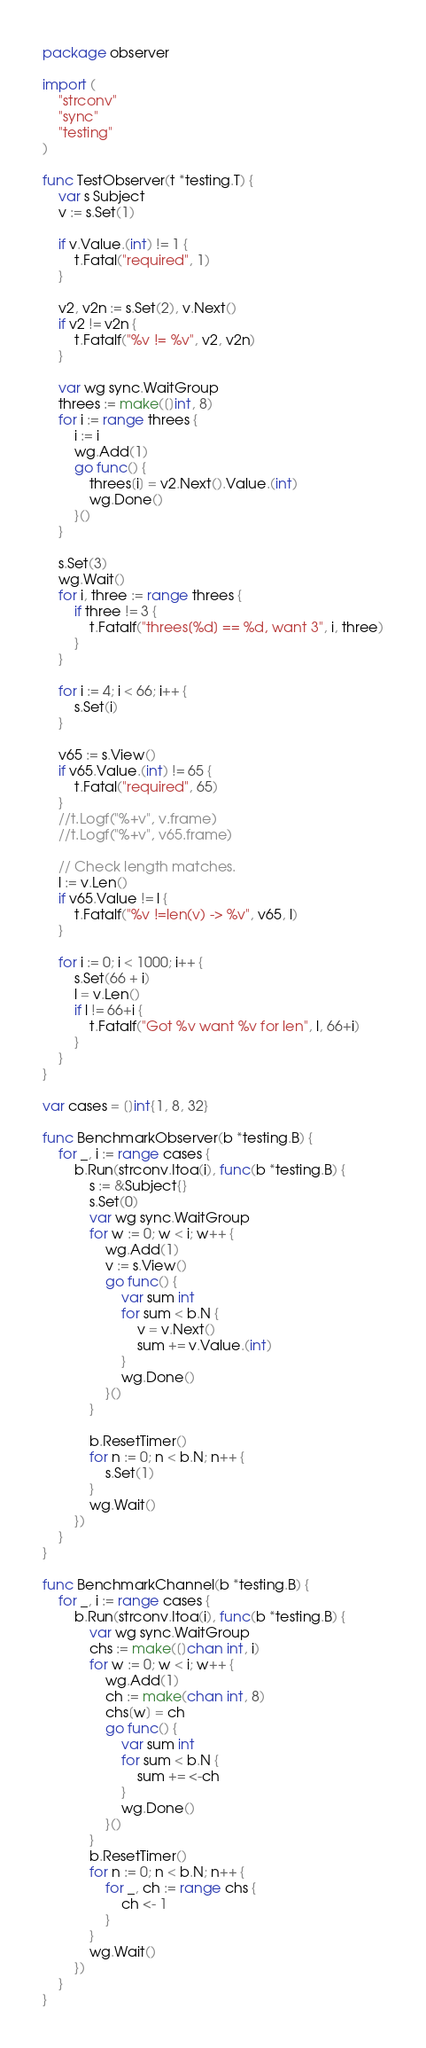Convert code to text. <code><loc_0><loc_0><loc_500><loc_500><_Go_>package observer

import (
	"strconv"
	"sync"
	"testing"
)

func TestObserver(t *testing.T) {
	var s Subject
	v := s.Set(1)

	if v.Value.(int) != 1 {
		t.Fatal("required", 1)
	}

	v2, v2n := s.Set(2), v.Next()
	if v2 != v2n {
		t.Fatalf("%v != %v", v2, v2n)
	}

	var wg sync.WaitGroup
	threes := make([]int, 8)
	for i := range threes {
		i := i
		wg.Add(1)
		go func() {
			threes[i] = v2.Next().Value.(int)
			wg.Done()
		}()
	}

	s.Set(3)
	wg.Wait()
	for i, three := range threes {
		if three != 3 {
			t.Fatalf("threes[%d] == %d, want 3", i, three)
		}
	}

	for i := 4; i < 66; i++ {
		s.Set(i)
	}

	v65 := s.View()
	if v65.Value.(int) != 65 {
		t.Fatal("required", 65)
	}
	//t.Logf("%+v", v.frame)
	//t.Logf("%+v", v65.frame)

	// Check length matches.
	l := v.Len()
	if v65.Value != l {
		t.Fatalf("%v !=len(v) -> %v", v65, l)
	}

	for i := 0; i < 1000; i++ {
		s.Set(66 + i)
		l = v.Len()
		if l != 66+i {
			t.Fatalf("Got %v want %v for len", l, 66+i)
		}
	}
}

var cases = []int{1, 8, 32}

func BenchmarkObserver(b *testing.B) {
	for _, i := range cases {
		b.Run(strconv.Itoa(i), func(b *testing.B) {
			s := &Subject{}
			s.Set(0)
			var wg sync.WaitGroup
			for w := 0; w < i; w++ {
				wg.Add(1)
				v := s.View()
				go func() {
					var sum int
					for sum < b.N {
						v = v.Next()
						sum += v.Value.(int)
					}
					wg.Done()
				}()
			}

			b.ResetTimer()
			for n := 0; n < b.N; n++ {
				s.Set(1)
			}
			wg.Wait()
		})
	}
}

func BenchmarkChannel(b *testing.B) {
	for _, i := range cases {
		b.Run(strconv.Itoa(i), func(b *testing.B) {
			var wg sync.WaitGroup
			chs := make([]chan int, i)
			for w := 0; w < i; w++ {
				wg.Add(1)
				ch := make(chan int, 8)
				chs[w] = ch
				go func() {
					var sum int
					for sum < b.N {
						sum += <-ch
					}
					wg.Done()
				}()
			}
			b.ResetTimer()
			for n := 0; n < b.N; n++ {
				for _, ch := range chs {
					ch <- 1
				}
			}
			wg.Wait()
		})
	}
}
</code> 